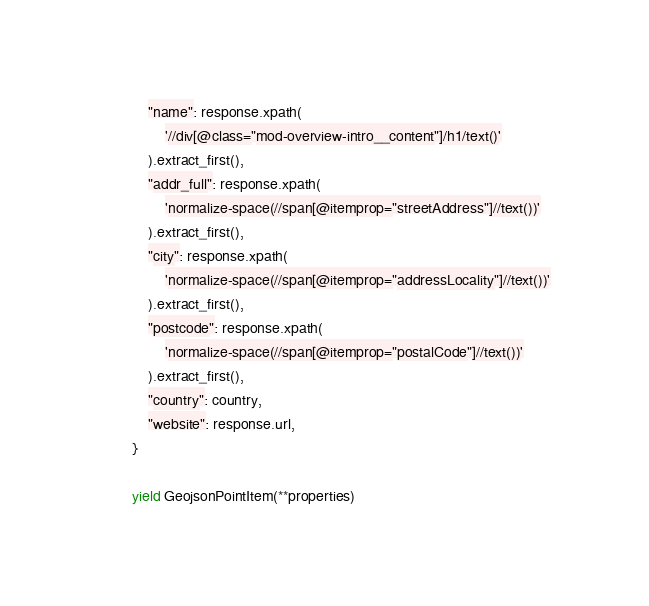<code> <loc_0><loc_0><loc_500><loc_500><_Python_>            "name": response.xpath(
                '//div[@class="mod-overview-intro__content"]/h1/text()'
            ).extract_first(),
            "addr_full": response.xpath(
                'normalize-space(//span[@itemprop="streetAddress"]//text())'
            ).extract_first(),
            "city": response.xpath(
                'normalize-space(//span[@itemprop="addressLocality"]//text())'
            ).extract_first(),
            "postcode": response.xpath(
                'normalize-space(//span[@itemprop="postalCode"]//text())'
            ).extract_first(),
            "country": country,
            "website": response.url,
        }

        yield GeojsonPointItem(**properties)
</code> 